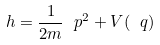<formula> <loc_0><loc_0><loc_500><loc_500>\ h = \frac { 1 } { 2 m } \ p ^ { 2 } + V ( \ q )</formula> 